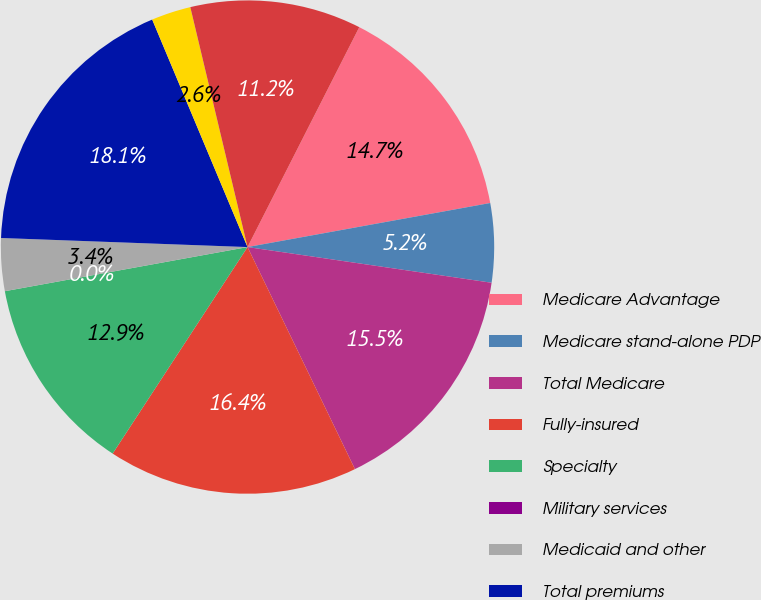Convert chart. <chart><loc_0><loc_0><loc_500><loc_500><pie_chart><fcel>Medicare Advantage<fcel>Medicare stand-alone PDP<fcel>Total Medicare<fcel>Fully-insured<fcel>Specialty<fcel>Military services<fcel>Medicaid and other<fcel>Total premiums<fcel>Provider<fcel>ASO and other<nl><fcel>14.66%<fcel>5.17%<fcel>15.52%<fcel>16.38%<fcel>12.93%<fcel>0.0%<fcel>3.45%<fcel>18.1%<fcel>2.59%<fcel>11.21%<nl></chart> 